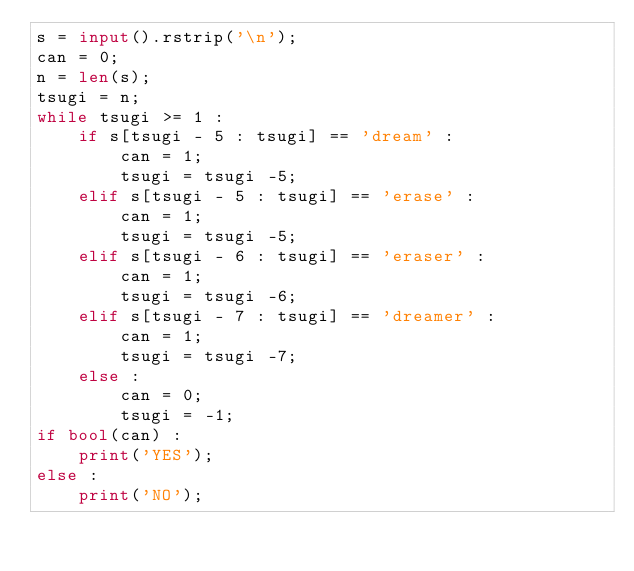Convert code to text. <code><loc_0><loc_0><loc_500><loc_500><_Python_>s = input().rstrip('\n');
can = 0;
n = len(s);
tsugi = n;
while tsugi >= 1 :
	if s[tsugi - 5 : tsugi] == 'dream' :
		can = 1;
		tsugi = tsugi -5;
	elif s[tsugi - 5 : tsugi] == 'erase' :
		can = 1;
		tsugi = tsugi -5;
	elif s[tsugi - 6 : tsugi] == 'eraser' :
		can = 1;
		tsugi = tsugi -6;
	elif s[tsugi - 7 : tsugi] == 'dreamer' :
		can = 1;
		tsugi = tsugi -7;
	else :
		can = 0;
		tsugi = -1;
if bool(can) :
	print('YES');
else :
	print('NO');</code> 